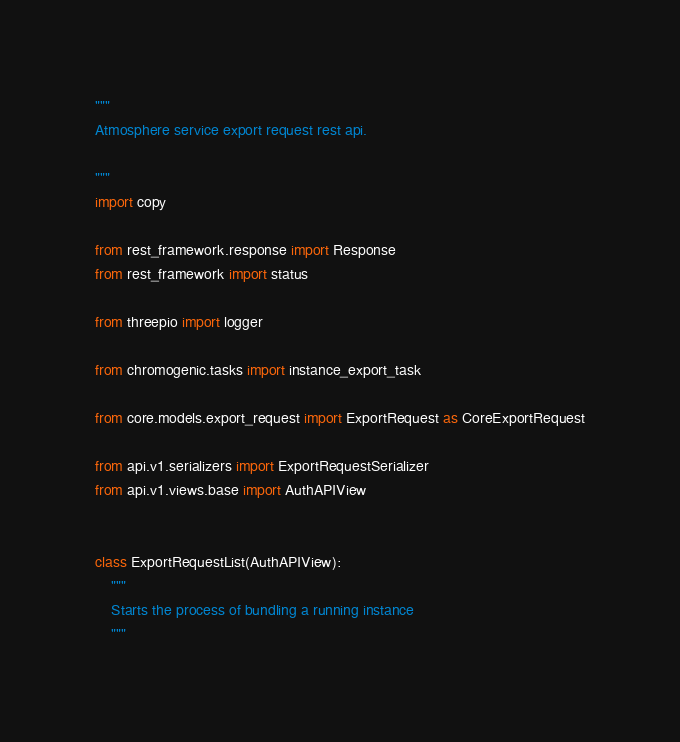Convert code to text. <code><loc_0><loc_0><loc_500><loc_500><_Python_>"""
Atmosphere service export request rest api.

"""
import copy

from rest_framework.response import Response
from rest_framework import status

from threepio import logger

from chromogenic.tasks import instance_export_task

from core.models.export_request import ExportRequest as CoreExportRequest

from api.v1.serializers import ExportRequestSerializer
from api.v1.views.base import AuthAPIView


class ExportRequestList(AuthAPIView):
    """
    Starts the process of bundling a running instance
    """
</code> 